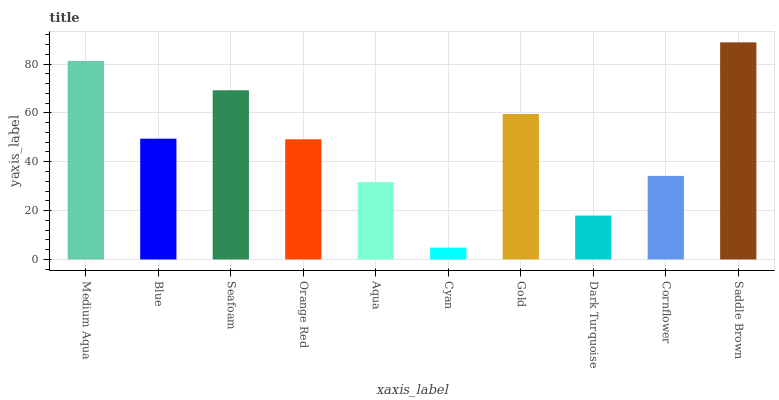Is Cyan the minimum?
Answer yes or no. Yes. Is Saddle Brown the maximum?
Answer yes or no. Yes. Is Blue the minimum?
Answer yes or no. No. Is Blue the maximum?
Answer yes or no. No. Is Medium Aqua greater than Blue?
Answer yes or no. Yes. Is Blue less than Medium Aqua?
Answer yes or no. Yes. Is Blue greater than Medium Aqua?
Answer yes or no. No. Is Medium Aqua less than Blue?
Answer yes or no. No. Is Blue the high median?
Answer yes or no. Yes. Is Orange Red the low median?
Answer yes or no. Yes. Is Cyan the high median?
Answer yes or no. No. Is Gold the low median?
Answer yes or no. No. 